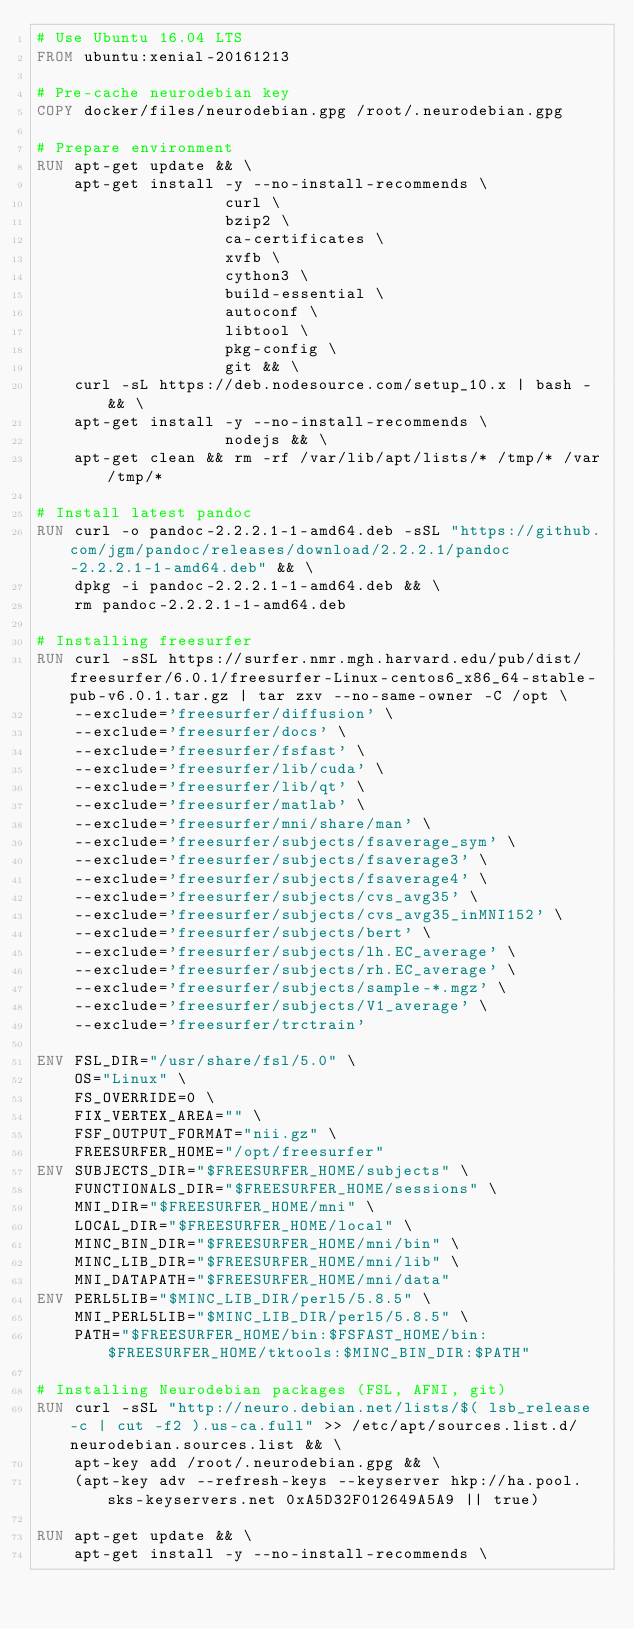Convert code to text. <code><loc_0><loc_0><loc_500><loc_500><_Dockerfile_># Use Ubuntu 16.04 LTS
FROM ubuntu:xenial-20161213

# Pre-cache neurodebian key
COPY docker/files/neurodebian.gpg /root/.neurodebian.gpg

# Prepare environment
RUN apt-get update && \
    apt-get install -y --no-install-recommends \
                    curl \
                    bzip2 \
                    ca-certificates \
                    xvfb \
                    cython3 \
                    build-essential \
                    autoconf \
                    libtool \
                    pkg-config \
                    git && \
    curl -sL https://deb.nodesource.com/setup_10.x | bash - && \
    apt-get install -y --no-install-recommends \
                    nodejs && \
    apt-get clean && rm -rf /var/lib/apt/lists/* /tmp/* /var/tmp/*

# Install latest pandoc
RUN curl -o pandoc-2.2.2.1-1-amd64.deb -sSL "https://github.com/jgm/pandoc/releases/download/2.2.2.1/pandoc-2.2.2.1-1-amd64.deb" && \
    dpkg -i pandoc-2.2.2.1-1-amd64.deb && \
    rm pandoc-2.2.2.1-1-amd64.deb

# Installing freesurfer
RUN curl -sSL https://surfer.nmr.mgh.harvard.edu/pub/dist/freesurfer/6.0.1/freesurfer-Linux-centos6_x86_64-stable-pub-v6.0.1.tar.gz | tar zxv --no-same-owner -C /opt \
    --exclude='freesurfer/diffusion' \
    --exclude='freesurfer/docs' \
    --exclude='freesurfer/fsfast' \
    --exclude='freesurfer/lib/cuda' \
    --exclude='freesurfer/lib/qt' \
    --exclude='freesurfer/matlab' \
    --exclude='freesurfer/mni/share/man' \
    --exclude='freesurfer/subjects/fsaverage_sym' \
    --exclude='freesurfer/subjects/fsaverage3' \
    --exclude='freesurfer/subjects/fsaverage4' \
    --exclude='freesurfer/subjects/cvs_avg35' \
    --exclude='freesurfer/subjects/cvs_avg35_inMNI152' \
    --exclude='freesurfer/subjects/bert' \
    --exclude='freesurfer/subjects/lh.EC_average' \
    --exclude='freesurfer/subjects/rh.EC_average' \
    --exclude='freesurfer/subjects/sample-*.mgz' \
    --exclude='freesurfer/subjects/V1_average' \
    --exclude='freesurfer/trctrain'

ENV FSL_DIR="/usr/share/fsl/5.0" \
    OS="Linux" \
    FS_OVERRIDE=0 \
    FIX_VERTEX_AREA="" \
    FSF_OUTPUT_FORMAT="nii.gz" \
    FREESURFER_HOME="/opt/freesurfer"
ENV SUBJECTS_DIR="$FREESURFER_HOME/subjects" \
    FUNCTIONALS_DIR="$FREESURFER_HOME/sessions" \
    MNI_DIR="$FREESURFER_HOME/mni" \
    LOCAL_DIR="$FREESURFER_HOME/local" \
    MINC_BIN_DIR="$FREESURFER_HOME/mni/bin" \
    MINC_LIB_DIR="$FREESURFER_HOME/mni/lib" \
    MNI_DATAPATH="$FREESURFER_HOME/mni/data"
ENV PERL5LIB="$MINC_LIB_DIR/perl5/5.8.5" \
    MNI_PERL5LIB="$MINC_LIB_DIR/perl5/5.8.5" \
    PATH="$FREESURFER_HOME/bin:$FSFAST_HOME/bin:$FREESURFER_HOME/tktools:$MINC_BIN_DIR:$PATH"

# Installing Neurodebian packages (FSL, AFNI, git)
RUN curl -sSL "http://neuro.debian.net/lists/$( lsb_release -c | cut -f2 ).us-ca.full" >> /etc/apt/sources.list.d/neurodebian.sources.list && \
    apt-key add /root/.neurodebian.gpg && \
    (apt-key adv --refresh-keys --keyserver hkp://ha.pool.sks-keyservers.net 0xA5D32F012649A5A9 || true)

RUN apt-get update && \
    apt-get install -y --no-install-recommends \</code> 